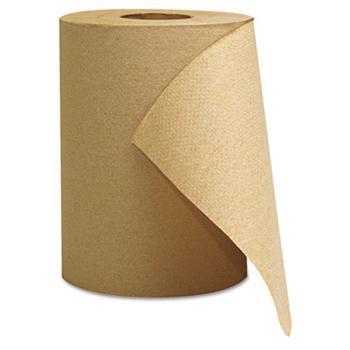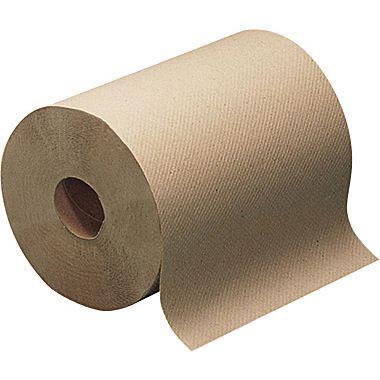The first image is the image on the left, the second image is the image on the right. Assess this claim about the two images: "The roll of brown paper in the image on the right is partially unrolled.". Correct or not? Answer yes or no. Yes. The first image is the image on the left, the second image is the image on the right. For the images displayed, is the sentence "There are two paper towel rolls" factually correct? Answer yes or no. Yes. 